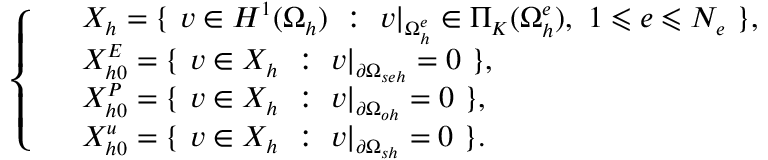Convert formula to latex. <formula><loc_0><loc_0><loc_500><loc_500>\left \{ \begin{array} { r l } & { X _ { h } = \{ \ v \in H ^ { 1 } ( \Omega _ { h } ) \ \colon \ v | _ { \Omega _ { h } ^ { e } } \in \Pi _ { K } ( \Omega _ { h } ^ { e } ) , \ 1 \leqslant e \leqslant N _ { e } \ \} , } \\ & { X _ { h 0 } ^ { E } = \{ \ v \in X _ { h } \ \colon \ v | _ { \partial \Omega _ { s e h } } = 0 \ \} , } \\ & { X _ { h 0 } ^ { P } = \{ \ v \in X _ { h } \ \colon \ v | _ { \partial \Omega _ { o h } } = 0 \ \} , } \\ & { X _ { h 0 } ^ { u } = \{ \ v \in X _ { h } \ \colon \ v | _ { \partial \Omega _ { s h } } = 0 \ \} . } \end{array}</formula> 